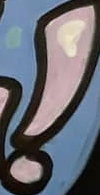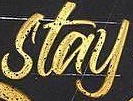What text is displayed in these images sequentially, separated by a semicolon? !; stay 